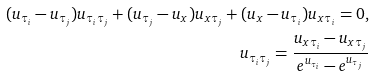<formula> <loc_0><loc_0><loc_500><loc_500>( u _ { \tau _ { i } } - u _ { \tau _ { j } } ) u _ { \tau _ { i } \tau _ { j } } + ( u _ { \tau _ { j } } - u _ { x } ) u _ { x \tau _ { j } } + ( u _ { x } - u _ { \tau _ { i } } ) u _ { x \tau _ { i } } = 0 , \\ u _ { \tau _ { i } \tau _ { j } } = \frac { u _ { x \tau _ { i } } - u _ { x \tau _ { j } } } { e ^ { u _ { \tau _ { i } } } - e ^ { u _ { \tau _ { j } } } }</formula> 